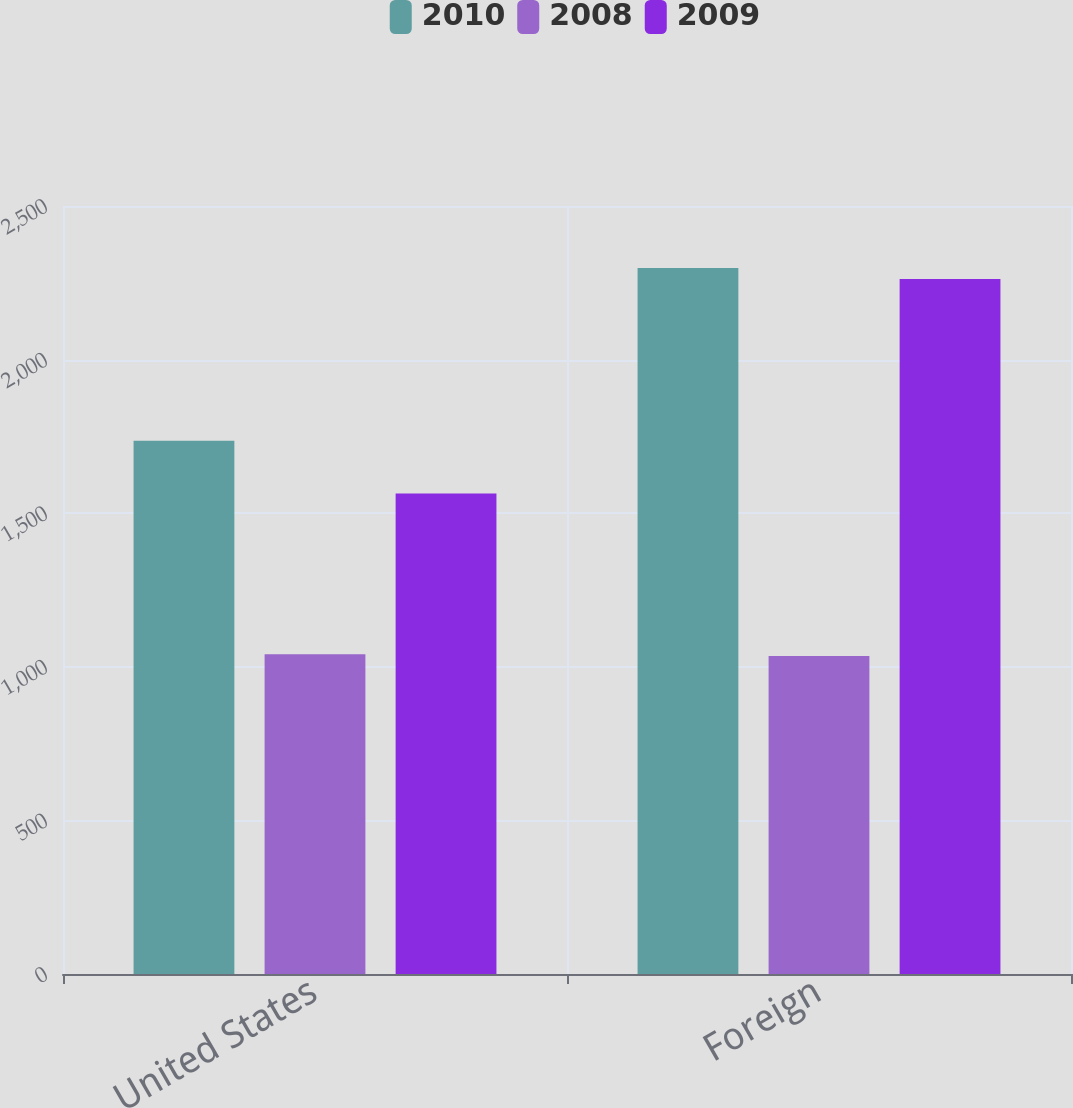Convert chart to OTSL. <chart><loc_0><loc_0><loc_500><loc_500><stacked_bar_chart><ecel><fcel>United States<fcel>Foreign<nl><fcel>2010<fcel>1736<fcel>2298<nl><fcel>2008<fcel>1041<fcel>1035<nl><fcel>2009<fcel>1564<fcel>2262<nl></chart> 